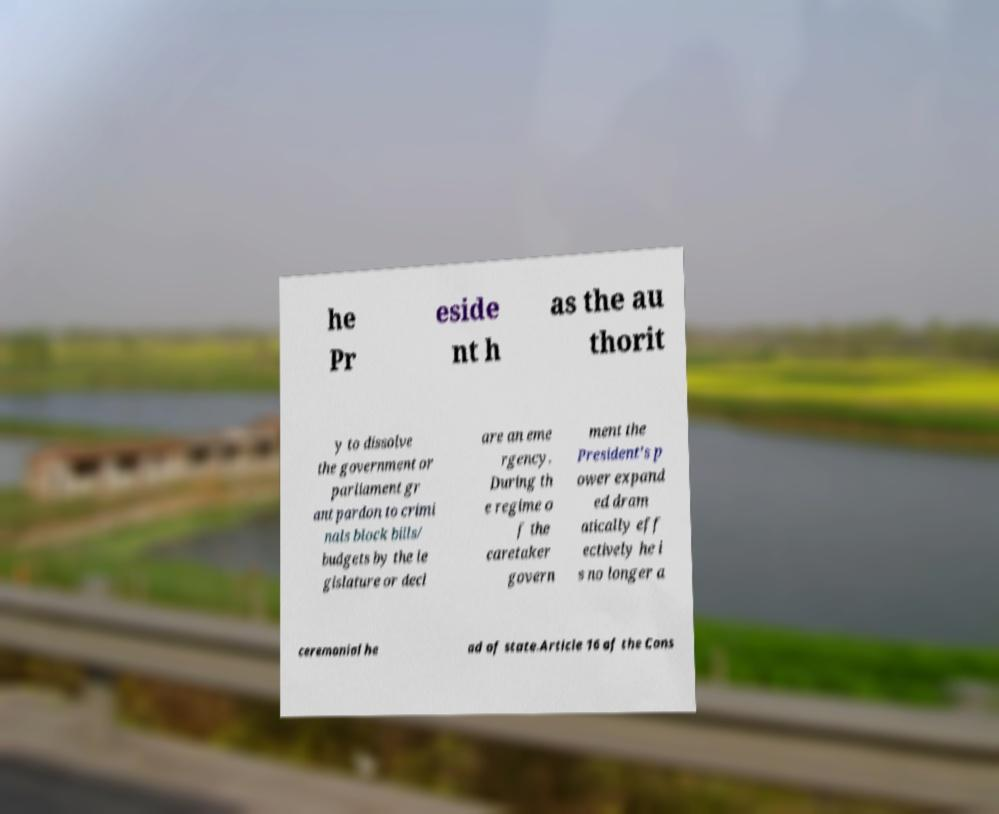There's text embedded in this image that I need extracted. Can you transcribe it verbatim? he Pr eside nt h as the au thorit y to dissolve the government or parliament gr ant pardon to crimi nals block bills/ budgets by the le gislature or decl are an eme rgency. During th e regime o f the caretaker govern ment the President's p ower expand ed dram atically eff ectively he i s no longer a ceremonial he ad of state.Article 16 of the Cons 